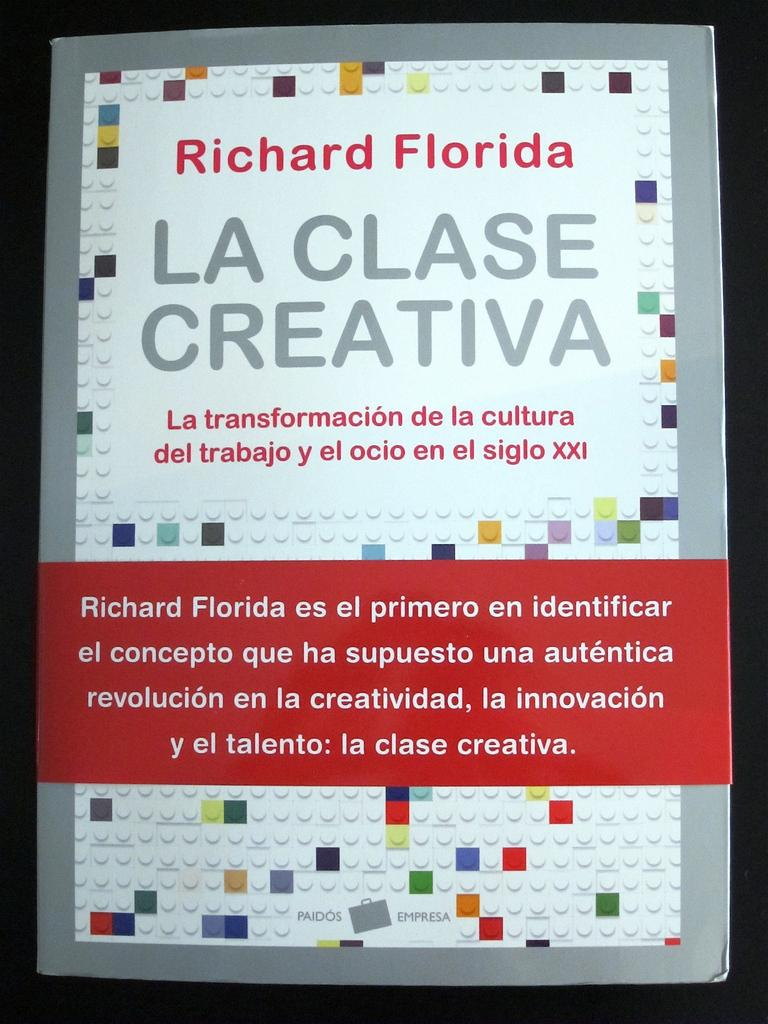<image>
Summarize the visual content of the image. Various colored Lego blocks on a white board showing the creative class. 